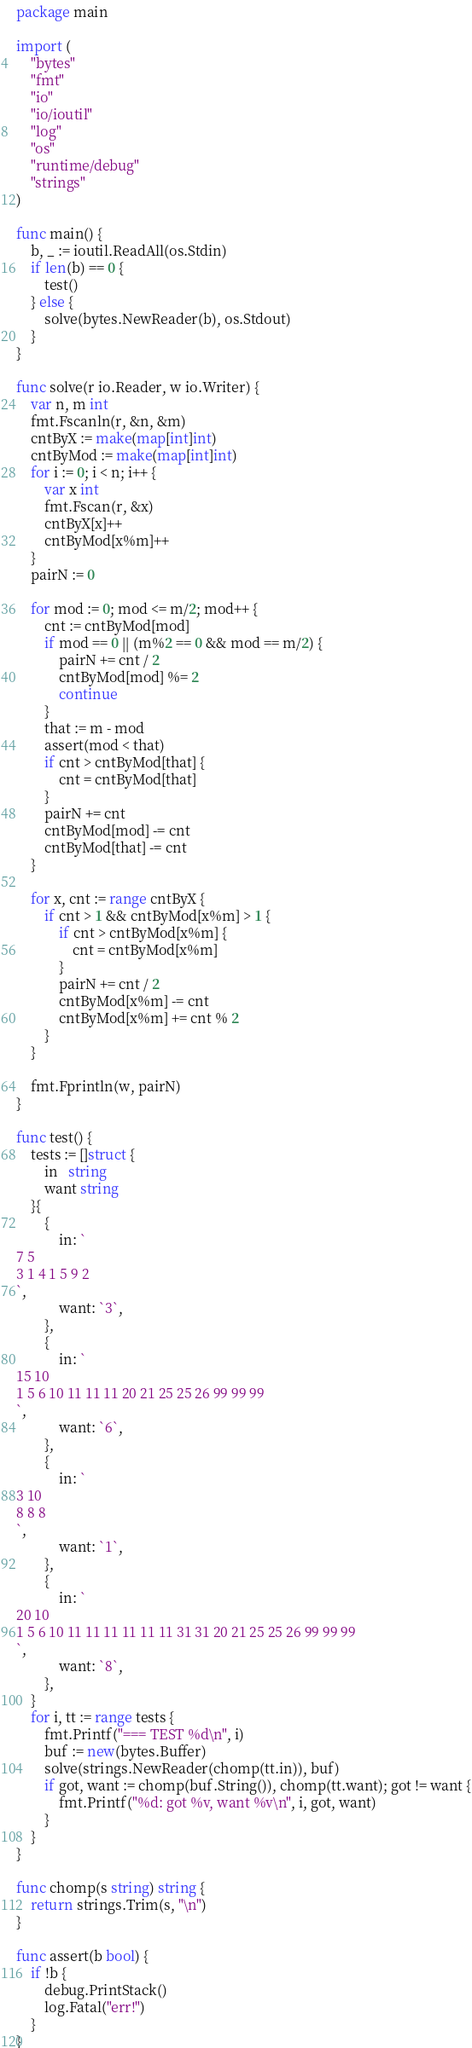Convert code to text. <code><loc_0><loc_0><loc_500><loc_500><_Go_>package main

import (
	"bytes"
	"fmt"
	"io"
	"io/ioutil"
	"log"
	"os"
	"runtime/debug"
	"strings"
)

func main() {
	b, _ := ioutil.ReadAll(os.Stdin)
	if len(b) == 0 {
		test()
	} else {
		solve(bytes.NewReader(b), os.Stdout)
	}
}

func solve(r io.Reader, w io.Writer) {
	var n, m int
	fmt.Fscanln(r, &n, &m)
	cntByX := make(map[int]int)
	cntByMod := make(map[int]int)
	for i := 0; i < n; i++ {
		var x int
		fmt.Fscan(r, &x)
		cntByX[x]++
		cntByMod[x%m]++
	}
	pairN := 0

	for mod := 0; mod <= m/2; mod++ {
		cnt := cntByMod[mod]
		if mod == 0 || (m%2 == 0 && mod == m/2) {
			pairN += cnt / 2
			cntByMod[mod] %= 2
			continue
		}
		that := m - mod
		assert(mod < that)
		if cnt > cntByMod[that] {
			cnt = cntByMod[that]
		}
		pairN += cnt
		cntByMod[mod] -= cnt
		cntByMod[that] -= cnt
	}

	for x, cnt := range cntByX {
		if cnt > 1 && cntByMod[x%m] > 1 {
			if cnt > cntByMod[x%m] {
				cnt = cntByMod[x%m]
			}
			pairN += cnt / 2
			cntByMod[x%m] -= cnt
			cntByMod[x%m] += cnt % 2
		}
	}

	fmt.Fprintln(w, pairN)
}

func test() {
	tests := []struct {
		in   string
		want string
	}{
		{
			in: `
7 5
3 1 4 1 5 9 2
`,
			want: `3`,
		},
		{
			in: `
15 10
1 5 6 10 11 11 11 20 21 25 25 26 99 99 99
`,
			want: `6`,
		},
		{
			in: `
3 10
8 8 8
`,
			want: `1`,
		},
		{
			in: `
20 10
1 5 6 10 11 11 11 11 11 11 31 31 20 21 25 25 26 99 99 99
`,
			want: `8`,
		},
	}
	for i, tt := range tests {
		fmt.Printf("=== TEST %d\n", i)
		buf := new(bytes.Buffer)
		solve(strings.NewReader(chomp(tt.in)), buf)
		if got, want := chomp(buf.String()), chomp(tt.want); got != want {
			fmt.Printf("%d: got %v, want %v\n", i, got, want)
		}
	}
}

func chomp(s string) string {
	return strings.Trim(s, "\n")
}

func assert(b bool) {
	if !b {
		debug.PrintStack()
		log.Fatal("err!")
	}
}
</code> 